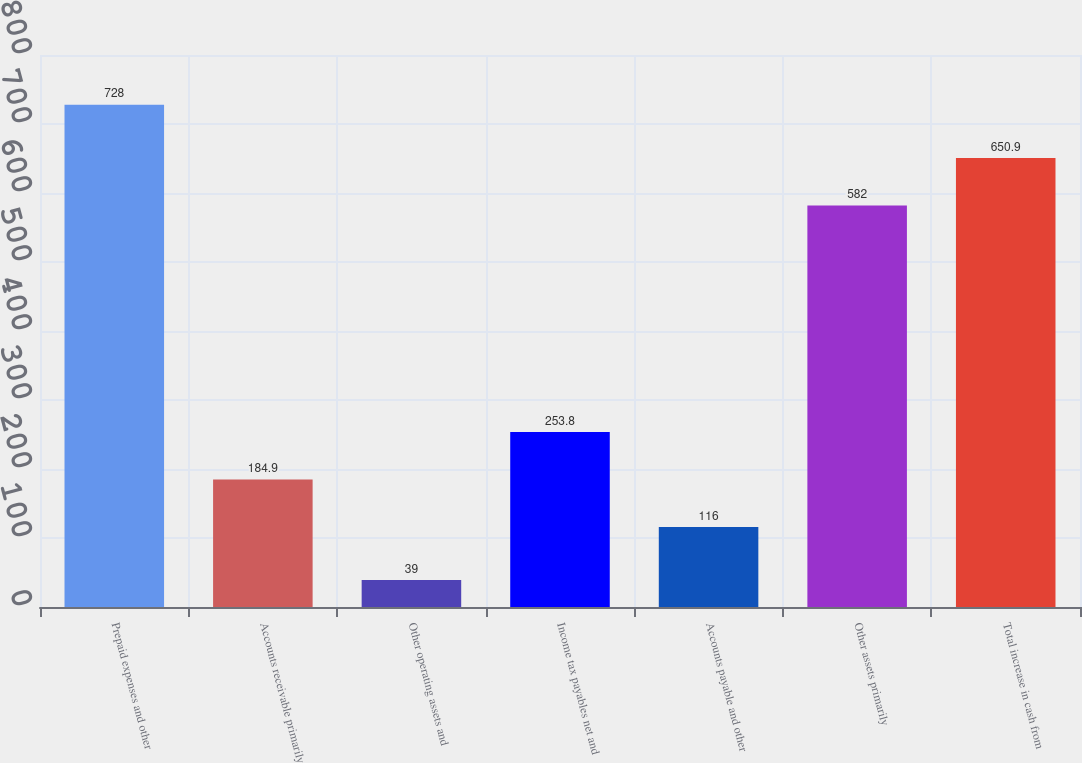<chart> <loc_0><loc_0><loc_500><loc_500><bar_chart><fcel>Prepaid expenses and other<fcel>Accounts receivable primarily<fcel>Other operating assets and<fcel>Income tax payables net and<fcel>Accounts payable and other<fcel>Other assets primarily<fcel>Total increase in cash from<nl><fcel>728<fcel>184.9<fcel>39<fcel>253.8<fcel>116<fcel>582<fcel>650.9<nl></chart> 